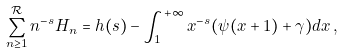<formula> <loc_0><loc_0><loc_500><loc_500>\sum _ { n \geq 1 } ^ { \mathcal { R } } n ^ { - s } H _ { n } = h ( s ) - \int _ { 1 } ^ { + \infty } x ^ { - s } ( \psi ( x + 1 ) + \gamma ) d x \, ,</formula> 